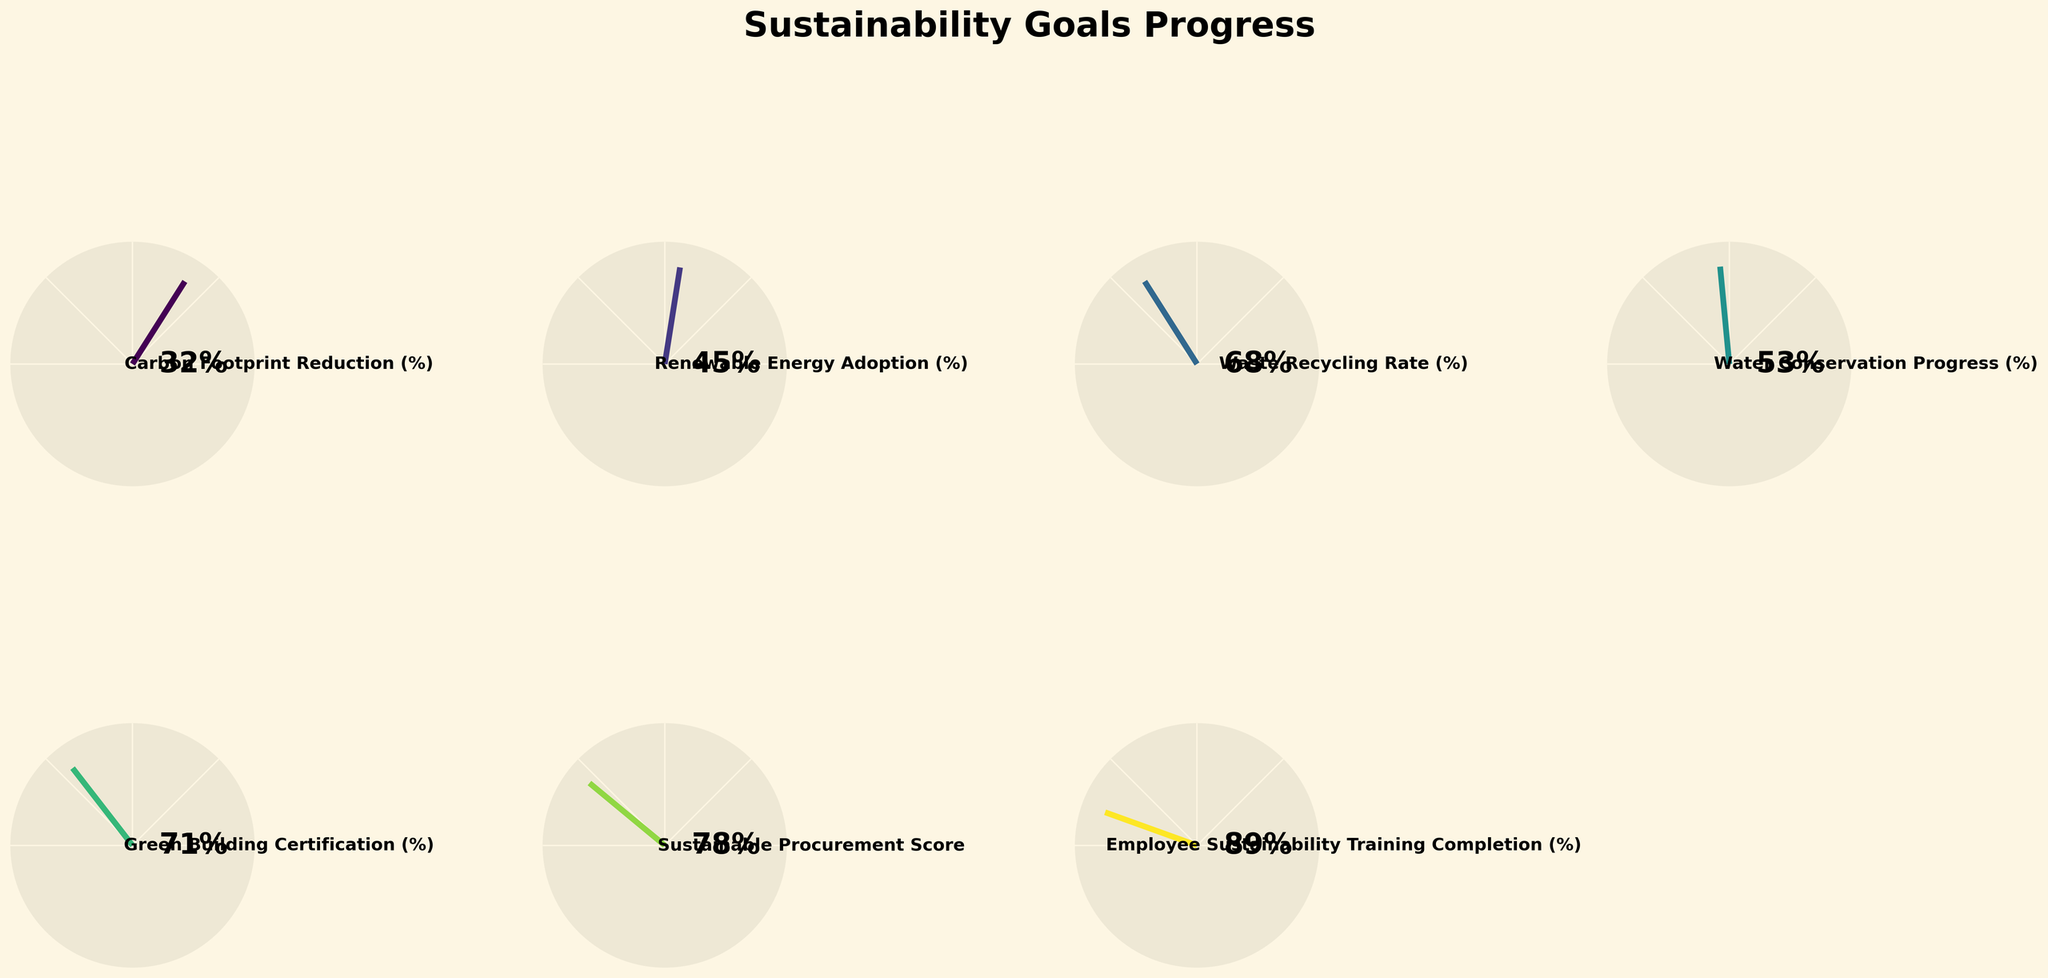What's the title of the figure? The title is written prominently at the top of the figure in large, bold font. It states the overall purpose of the visual.
Answer: Sustainability Goals Progress What metric has the highest completion percentage? The figure displays percentage values prominently in the middle of each gauge chart. The highest completion percentage is identified by comparing these numbers.
Answer: Employee Sustainability Training Completion (%) What is the range of values shown in each gauge chart? Each gauge chart has a scale from the minimum value to the maximum value, which are indicated near the ends of the gauge. By observing these scales, one can identify the range.
Answer: 0 to 100 Which metric has the lowest progress percentage? By examining the percentage values displayed in each gauge chart, the metric with the smallest percentage can be identified.
Answer: Carbon Footprint Reduction (%) Calculate the difference between the highest and lowest progress percentages. Identify the highest and lowest percentage values from the gauge charts. Subtract the lowest value from the highest value to get the difference. Highest is 89% (Employee Sustainability Training), and lowest is 32% (Carbon Footprint Reduction), so the difference is 89 - 32 = 57.
Answer: 57 Which two metrics have values greater than 70%? Check each gauge chart for values greater than 70%. Two charts have values of 71% and 89%.
Answer: Green Building Certification (%) and Employee Sustainability Training Completion (%) What is the average progress percentage of all the metrics? Add all the given percentage values and divide by the number of metrics (7 metrics). (32 + 45 + 68 + 53 + 71 + 78 + 89) / 7 = 62.29.
Answer: 62.29 Compare the Renewable Energy Adoption percentage with the Waste Recycling Rate percentage. Which is higher? Look at the percentage values for both metrics and compare them directly. Renewable Energy Adoption is 45% and Waste Recycling Rate is 68%, so Waste Recycling Rate is higher.
Answer: Waste Recycling Rate (%) What is the most common color theme used in the gauge charts? Look at the colors used in the gauge charts and see if a pattern or predominant color theme can be identified, which in this case is a gradient from the Viridis colormap.
Answer: Gradient from Viridis colormap Which metric is closest to 50% progress? Identify the percentage closest to 50% by comparing all the values. Water Conservation Progress is at 53%, which is closest.
Answer: Water Conservation Progress (%) 